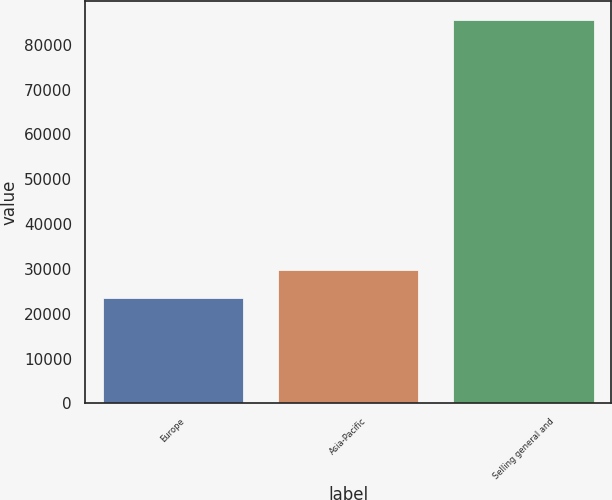Convert chart. <chart><loc_0><loc_0><loc_500><loc_500><bar_chart><fcel>Europe<fcel>Asia-Pacific<fcel>Selling general and<nl><fcel>23577<fcel>29772.2<fcel>85529<nl></chart> 